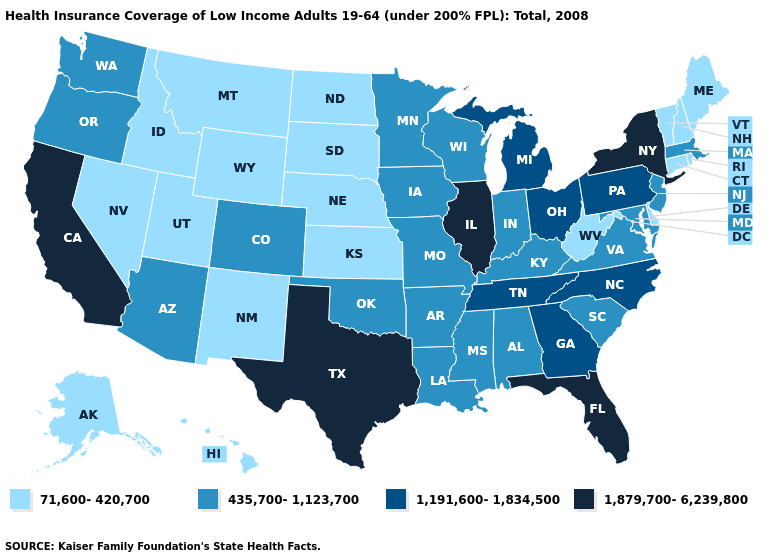What is the highest value in the USA?
Keep it brief. 1,879,700-6,239,800. Name the states that have a value in the range 71,600-420,700?
Give a very brief answer. Alaska, Connecticut, Delaware, Hawaii, Idaho, Kansas, Maine, Montana, Nebraska, Nevada, New Hampshire, New Mexico, North Dakota, Rhode Island, South Dakota, Utah, Vermont, West Virginia, Wyoming. What is the lowest value in states that border Oklahoma?
Quick response, please. 71,600-420,700. How many symbols are there in the legend?
Answer briefly. 4. Which states hav the highest value in the South?
Answer briefly. Florida, Texas. Name the states that have a value in the range 71,600-420,700?
Give a very brief answer. Alaska, Connecticut, Delaware, Hawaii, Idaho, Kansas, Maine, Montana, Nebraska, Nevada, New Hampshire, New Mexico, North Dakota, Rhode Island, South Dakota, Utah, Vermont, West Virginia, Wyoming. Name the states that have a value in the range 71,600-420,700?
Keep it brief. Alaska, Connecticut, Delaware, Hawaii, Idaho, Kansas, Maine, Montana, Nebraska, Nevada, New Hampshire, New Mexico, North Dakota, Rhode Island, South Dakota, Utah, Vermont, West Virginia, Wyoming. Name the states that have a value in the range 1,879,700-6,239,800?
Be succinct. California, Florida, Illinois, New York, Texas. Among the states that border North Dakota , which have the highest value?
Write a very short answer. Minnesota. Does the first symbol in the legend represent the smallest category?
Concise answer only. Yes. Among the states that border Nevada , does Idaho have the highest value?
Answer briefly. No. What is the value of Rhode Island?
Give a very brief answer. 71,600-420,700. Among the states that border Wyoming , does Colorado have the highest value?
Write a very short answer. Yes. What is the value of Michigan?
Be succinct. 1,191,600-1,834,500. 